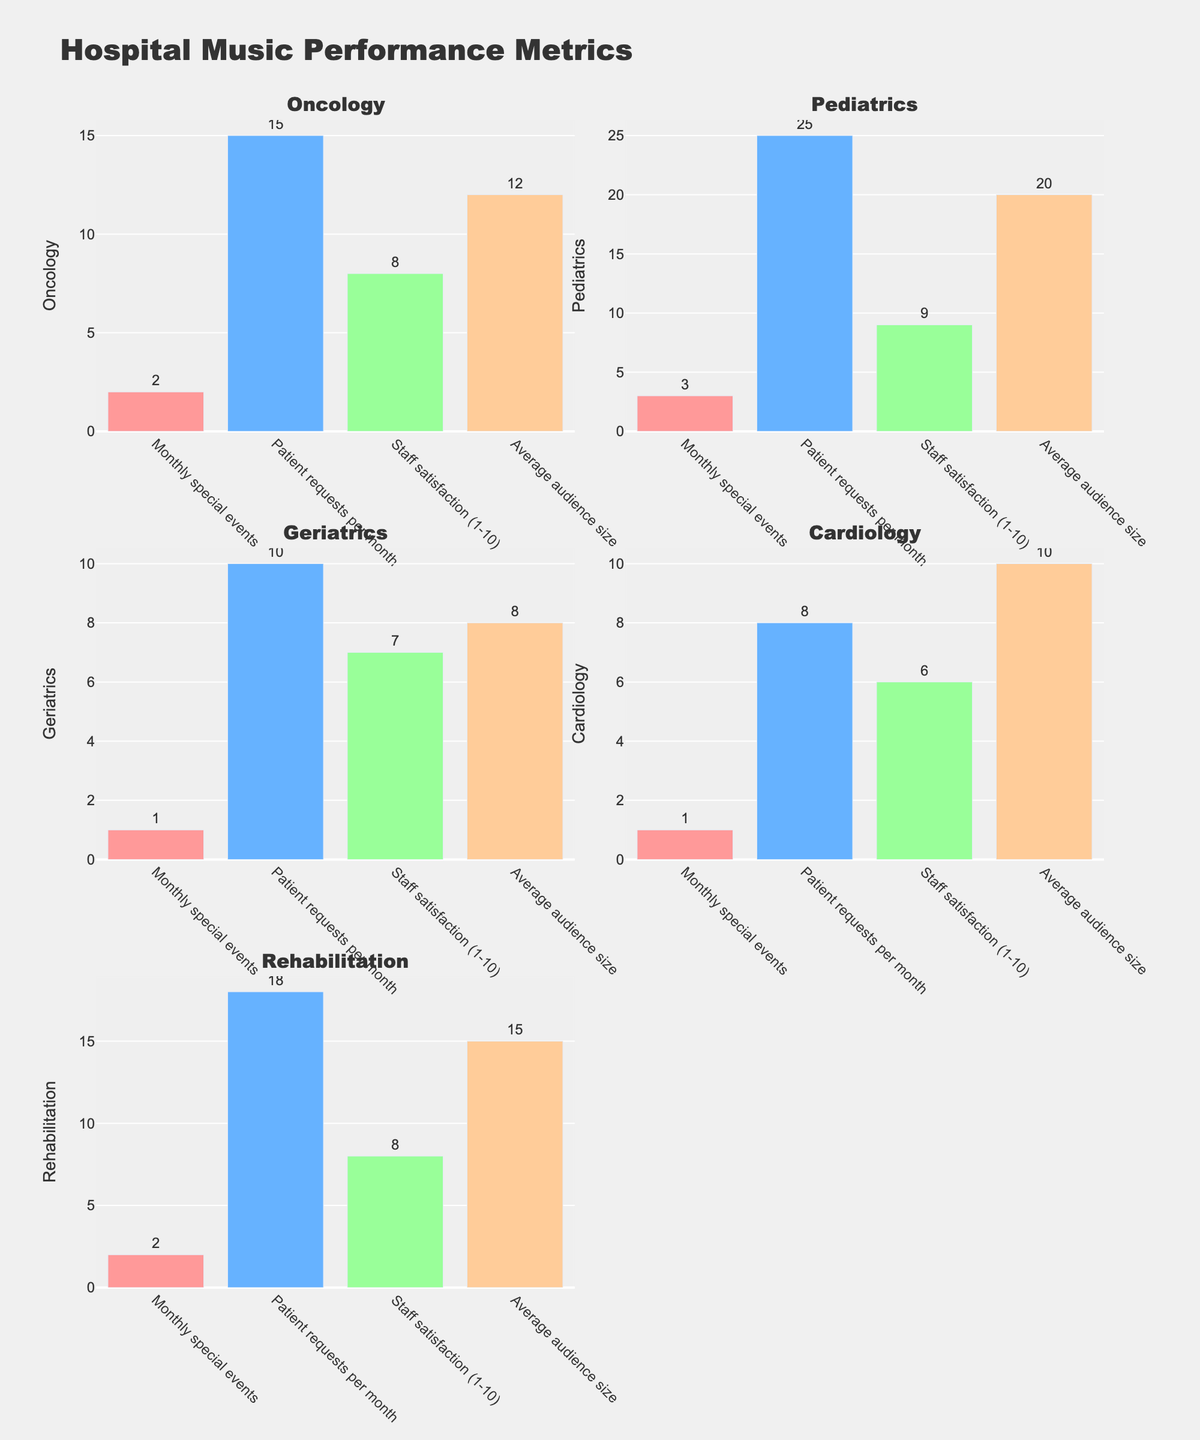What is the title of the figure? The figure's title is usually displayed prominently at the top of the chart. Upon examining the plot, we can see the main title.
Answer: Hospital Music Performance Metrics In which department do visiting musicians have the highest number of weekly performances? By looking at the bar heights in the subplot titled "Weekly performances," the department with the tallest bar represents the highest number of weekly performances.
Answer: Pediatrics What is the difference in weekly performances between the department with the most and the least performances? Identify the highest value (Pediatrics, 5) and the lowest value (Cardiology, 1) in the "Weekly performances" subplot, then subtract the lowest from the highest.
Answer: 4 How many monthly special events are held in the Oncology and Rehabilitation departments combined? Identify the values for "Monthly special events" in the Oncology (2) and Rehabilitation (2) departments, then add them together.
Answer: 4 Which department has the highest staff satisfaction level, and what is that level? Look at the "Staff satisfaction (1-10)" subplot and find the tallest bar; the corresponding department is Pediatrics with a satisfaction level of 9.
Answer: Pediatrics, 9 How does the average audience size in Pediatrics compare to Geriatrics? Compare the bar heights in the "Average audience size" subplot for Pediatrics (20) and Geriatrics (8).
Answer: Pediatrics has a larger average audience size Which department has the fewest patient requests per month, and how many requests do they have? Find the smallest bar in the "Patient requests per month" subplot, which corresponds to Cardiology with 8 requests.
Answer: Cardiology, 8 What is the total number of weekly performances across all departments? Sum the values of the bars in the "Weekly performances" subplot: 3 (Oncology) + 5 (Pediatrics) + 2 (Geriatrics) + 1 (Cardiology) + 4 (Rehabilitation).
Answer: 15 Is the number of special events in Pediatrics greater than, less than, or equal to those in Cardiology? Compare the bar heights in the "Monthly special events" subplot for Pediatrics (3) and Cardiology (1).
Answer: Greater than How does the staff satisfaction in Rehabilitation compare to Oncology? Compare the bar heights in the "Staff satisfaction (1-10)" subplot for Rehabilitation (8) and Oncology (8).
Answer: Equal to 